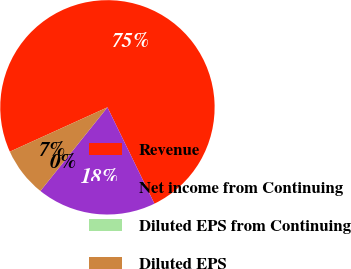Convert chart to OTSL. <chart><loc_0><loc_0><loc_500><loc_500><pie_chart><fcel>Revenue<fcel>Net income from Continuing<fcel>Diluted EPS from Continuing<fcel>Diluted EPS<nl><fcel>74.57%<fcel>17.98%<fcel>0.0%<fcel>7.46%<nl></chart> 